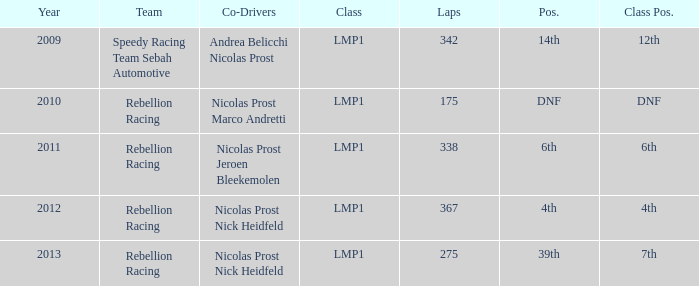If the year is pre-2013 and the number of laps surpasses 175, what is the class pos.? 12th, 6th, 4th. 